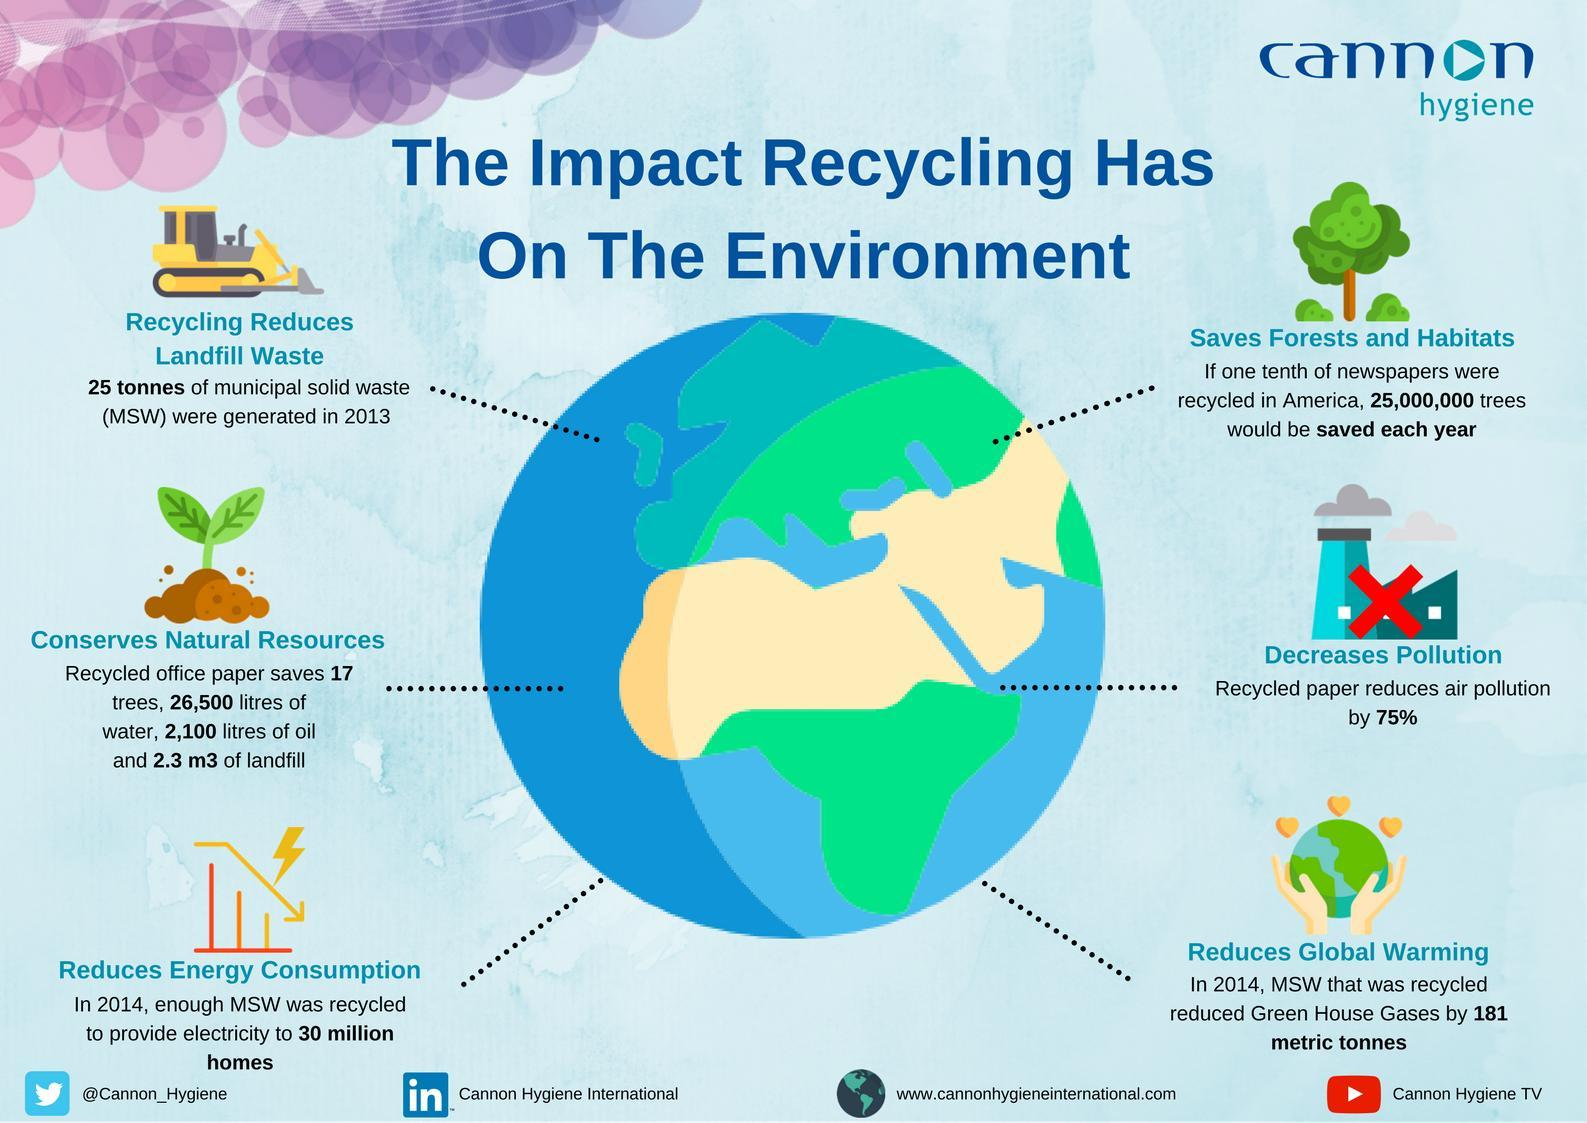What is the percentage reduction in air pollution by recycled papers?
Answer the question with a short phrase. 75% How many trees would be saved each year if one-tenth of newspapers were recycled in America? 25,000,000 What amount of green house gases were reduced by recycling the municipal solid waste in 2014? 181 metric tonnes 